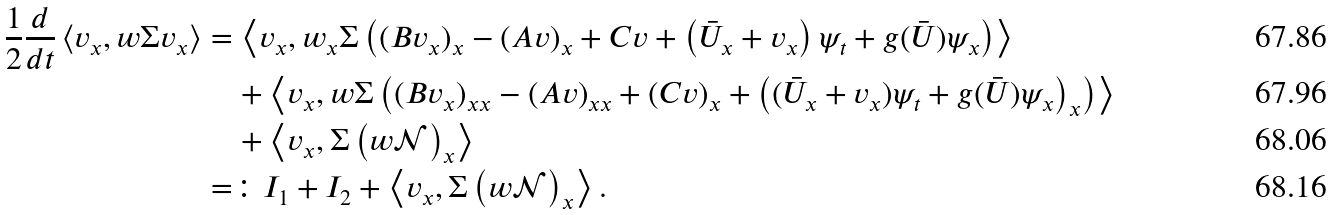Convert formula to latex. <formula><loc_0><loc_0><loc_500><loc_500>\frac { 1 } { 2 } \frac { d } { d t } \left < v _ { x } , w \Sigma v _ { x } \right > & = \left < v _ { x } , w _ { x } \Sigma \left ( ( B v _ { x } ) _ { x } - ( A v ) _ { x } + C v + \left ( \bar { U } _ { x } + v _ { x } \right ) \psi _ { t } + g ( \bar { U } ) \psi _ { x } \right ) \right > \\ & \quad + \left < v _ { x } , w \Sigma \left ( ( B v _ { x } ) _ { x x } - ( A v ) _ { x x } + ( C v ) _ { x } + \left ( ( \bar { U } _ { x } + v _ { x } ) \psi _ { t } + g ( \bar { U } ) \psi _ { x } \right ) _ { x } \right ) \right > \\ & \quad + \left < v _ { x } , \Sigma \left ( w \mathcal { N } \right ) _ { x } \right > \\ & = \colon I _ { 1 } + I _ { 2 } + \left < v _ { x } , \Sigma \left ( w \mathcal { N } \right ) _ { x } \right > .</formula> 